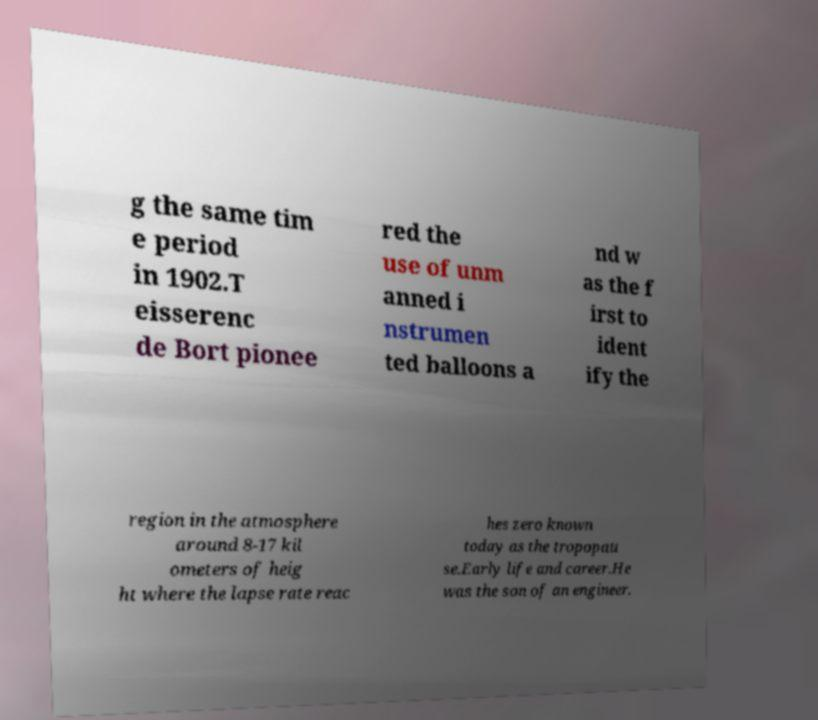Can you read and provide the text displayed in the image?This photo seems to have some interesting text. Can you extract and type it out for me? g the same tim e period in 1902.T eisserenc de Bort pionee red the use of unm anned i nstrumen ted balloons a nd w as the f irst to ident ify the region in the atmosphere around 8-17 kil ometers of heig ht where the lapse rate reac hes zero known today as the tropopau se.Early life and career.He was the son of an engineer. 